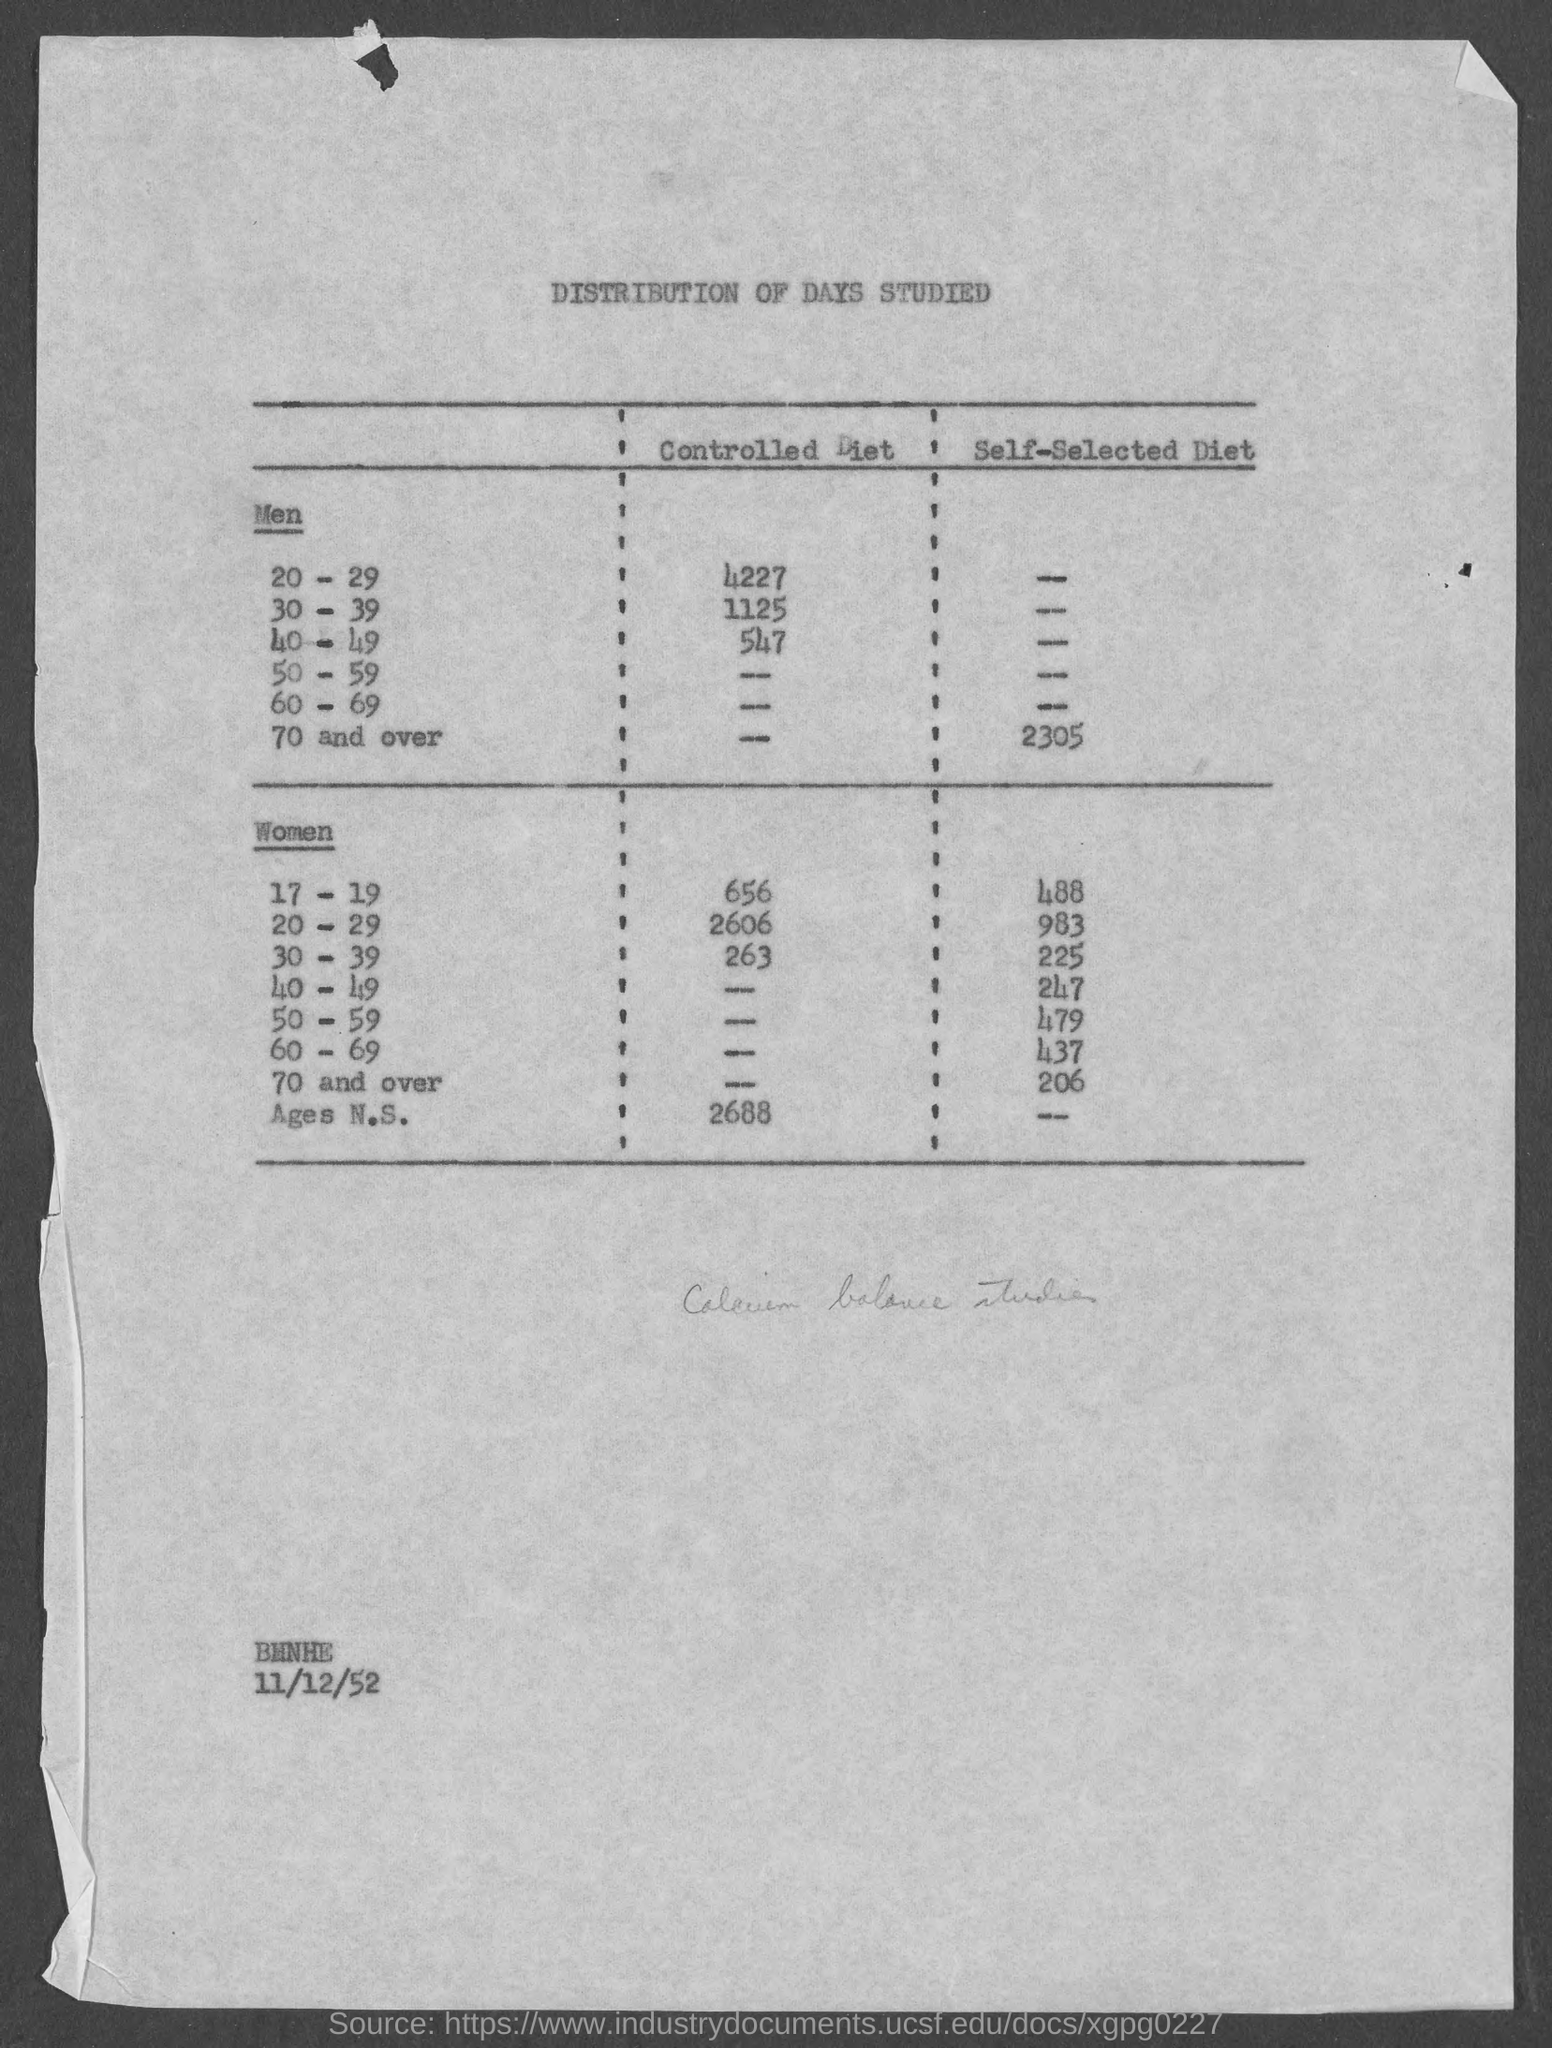What is the Title of the document?
Your response must be concise. Distribution of days studied. What is the value for controlled diet for Men 20-29?
Keep it short and to the point. 4227. What is the value for controlled diet for Men 30-39?
Provide a succinct answer. 1125. What is the value for controlled diet for Men 40-49?
Provide a short and direct response. 547. What is the value for self-selected diet for Women 40-49?
Your response must be concise. 247. What is the value for self-selected diet for Women 17-19?
Your response must be concise. 488. What is the value for self-selected diet for Women 20-29?
Your response must be concise. 983. What is the value for self-selected diet for Women 30-39?
Keep it short and to the point. 225. What is the value for self-selected diet for Women 50-59?
Offer a very short reply. 479. What is the value for self-selected diet for Women 60-69?
Provide a short and direct response. 437. 